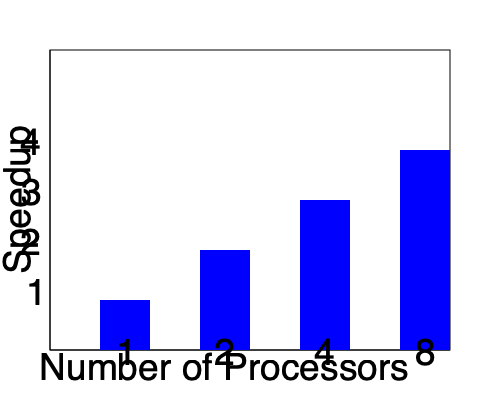Given the bar graph showing the speedup achieved with different numbers of processors in a parallel computing system, calculate the parallel efficiency for the 8-processor configuration. Express your answer as a percentage rounded to the nearest whole number. To calculate the parallel efficiency for the 8-processor configuration, we'll follow these steps:

1. Identify the speedup for 8 processors:
   From the graph, we can see that the bar for 8 processors reaches a height of 4 on the speedup axis.

2. Recall the formula for parallel efficiency:
   $$ \text{Efficiency} = \frac{\text{Speedup}}{\text{Number of Processors}} \times 100\% $$

3. Substitute the values:
   $$ \text{Efficiency} = \frac{4}{8} \times 100\% $$

4. Perform the calculation:
   $$ \text{Efficiency} = 0.5 \times 100\% = 50\% $$

5. Round to the nearest whole number:
   The result is already a whole number, so no rounding is necessary.

The parallel efficiency for the 8-processor configuration is 50%.
Answer: 50% 